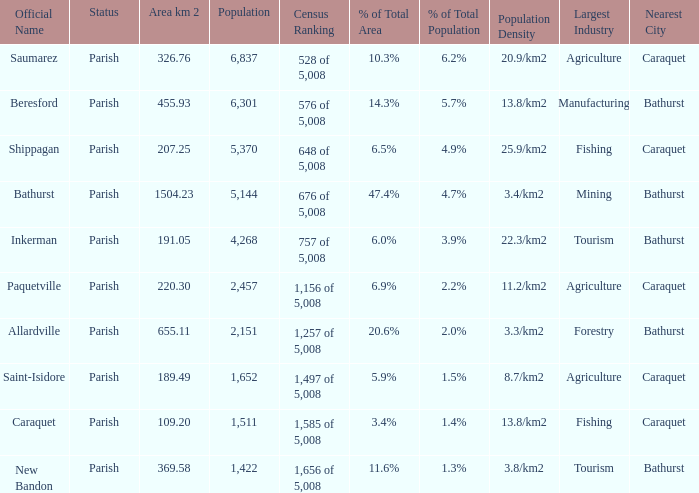What is the Population of the New Bandon Parish with an Area km 2 larger than 326.76? 1422.0. 